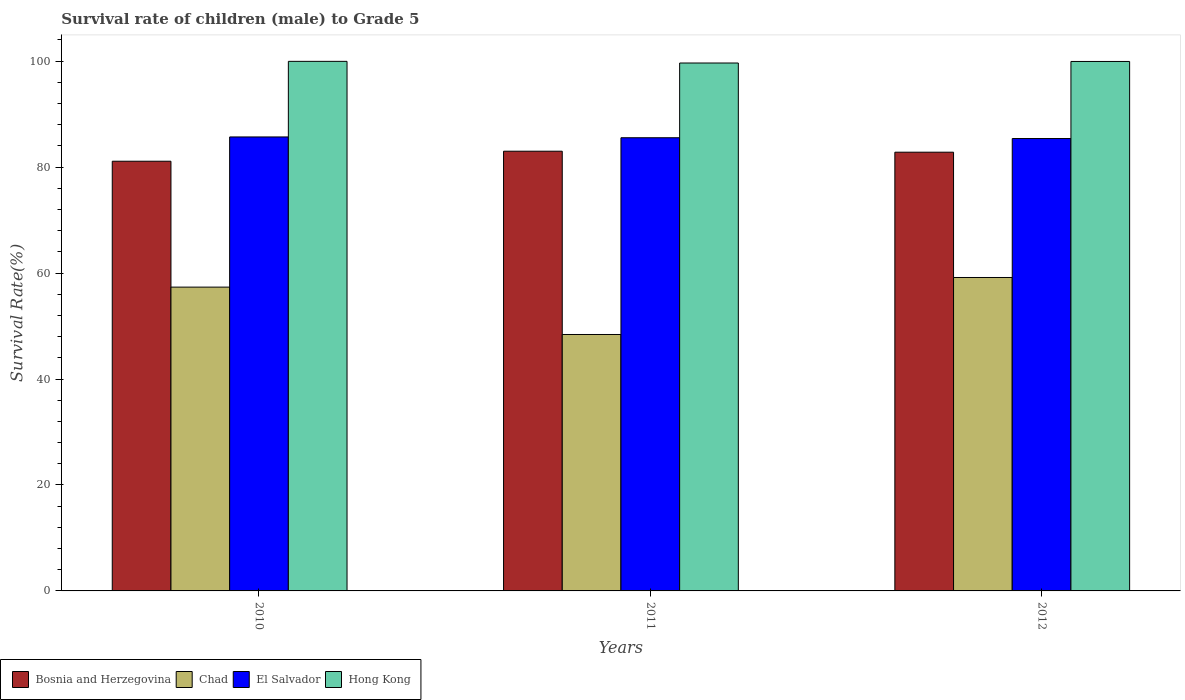How many different coloured bars are there?
Give a very brief answer. 4. Are the number of bars on each tick of the X-axis equal?
Provide a succinct answer. Yes. What is the survival rate of male children to grade 5 in El Salvador in 2011?
Your answer should be compact. 85.55. Across all years, what is the maximum survival rate of male children to grade 5 in Chad?
Provide a succinct answer. 59.17. Across all years, what is the minimum survival rate of male children to grade 5 in Hong Kong?
Provide a succinct answer. 99.65. In which year was the survival rate of male children to grade 5 in El Salvador minimum?
Provide a short and direct response. 2012. What is the total survival rate of male children to grade 5 in Bosnia and Herzegovina in the graph?
Ensure brevity in your answer.  246.93. What is the difference between the survival rate of male children to grade 5 in Chad in 2011 and that in 2012?
Your answer should be compact. -10.76. What is the difference between the survival rate of male children to grade 5 in Chad in 2011 and the survival rate of male children to grade 5 in Bosnia and Herzegovina in 2012?
Provide a short and direct response. -34.41. What is the average survival rate of male children to grade 5 in Hong Kong per year?
Provide a short and direct response. 99.85. In the year 2011, what is the difference between the survival rate of male children to grade 5 in Chad and survival rate of male children to grade 5 in Bosnia and Herzegovina?
Ensure brevity in your answer.  -34.6. What is the ratio of the survival rate of male children to grade 5 in El Salvador in 2010 to that in 2011?
Make the answer very short. 1. Is the difference between the survival rate of male children to grade 5 in Chad in 2010 and 2011 greater than the difference between the survival rate of male children to grade 5 in Bosnia and Herzegovina in 2010 and 2011?
Provide a succinct answer. Yes. What is the difference between the highest and the second highest survival rate of male children to grade 5 in El Salvador?
Make the answer very short. 0.15. What is the difference between the highest and the lowest survival rate of male children to grade 5 in El Salvador?
Keep it short and to the point. 0.3. In how many years, is the survival rate of male children to grade 5 in El Salvador greater than the average survival rate of male children to grade 5 in El Salvador taken over all years?
Provide a succinct answer. 2. What does the 4th bar from the left in 2011 represents?
Your answer should be very brief. Hong Kong. What does the 4th bar from the right in 2012 represents?
Your answer should be compact. Bosnia and Herzegovina. Is it the case that in every year, the sum of the survival rate of male children to grade 5 in Chad and survival rate of male children to grade 5 in Bosnia and Herzegovina is greater than the survival rate of male children to grade 5 in El Salvador?
Make the answer very short. Yes. Are all the bars in the graph horizontal?
Your response must be concise. No. What is the difference between two consecutive major ticks on the Y-axis?
Your answer should be very brief. 20. Are the values on the major ticks of Y-axis written in scientific E-notation?
Your answer should be very brief. No. Does the graph contain grids?
Make the answer very short. No. How are the legend labels stacked?
Provide a short and direct response. Horizontal. What is the title of the graph?
Your answer should be compact. Survival rate of children (male) to Grade 5. Does "Liechtenstein" appear as one of the legend labels in the graph?
Make the answer very short. No. What is the label or title of the X-axis?
Make the answer very short. Years. What is the label or title of the Y-axis?
Keep it short and to the point. Survival Rate(%). What is the Survival Rate(%) of Bosnia and Herzegovina in 2010?
Offer a very short reply. 81.11. What is the Survival Rate(%) in Chad in 2010?
Offer a very short reply. 57.35. What is the Survival Rate(%) in El Salvador in 2010?
Make the answer very short. 85.7. What is the Survival Rate(%) of Hong Kong in 2010?
Your answer should be compact. 99.96. What is the Survival Rate(%) in Bosnia and Herzegovina in 2011?
Your answer should be very brief. 83. What is the Survival Rate(%) of Chad in 2011?
Give a very brief answer. 48.41. What is the Survival Rate(%) of El Salvador in 2011?
Your answer should be compact. 85.55. What is the Survival Rate(%) in Hong Kong in 2011?
Give a very brief answer. 99.65. What is the Survival Rate(%) in Bosnia and Herzegovina in 2012?
Make the answer very short. 82.82. What is the Survival Rate(%) of Chad in 2012?
Provide a short and direct response. 59.17. What is the Survival Rate(%) of El Salvador in 2012?
Provide a short and direct response. 85.4. What is the Survival Rate(%) in Hong Kong in 2012?
Your answer should be compact. 99.95. Across all years, what is the maximum Survival Rate(%) in Bosnia and Herzegovina?
Provide a succinct answer. 83. Across all years, what is the maximum Survival Rate(%) in Chad?
Make the answer very short. 59.17. Across all years, what is the maximum Survival Rate(%) of El Salvador?
Offer a very short reply. 85.7. Across all years, what is the maximum Survival Rate(%) of Hong Kong?
Make the answer very short. 99.96. Across all years, what is the minimum Survival Rate(%) in Bosnia and Herzegovina?
Make the answer very short. 81.11. Across all years, what is the minimum Survival Rate(%) in Chad?
Ensure brevity in your answer.  48.41. Across all years, what is the minimum Survival Rate(%) of El Salvador?
Make the answer very short. 85.4. Across all years, what is the minimum Survival Rate(%) of Hong Kong?
Give a very brief answer. 99.65. What is the total Survival Rate(%) of Bosnia and Herzegovina in the graph?
Offer a terse response. 246.93. What is the total Survival Rate(%) in Chad in the graph?
Give a very brief answer. 164.92. What is the total Survival Rate(%) of El Salvador in the graph?
Your answer should be very brief. 256.64. What is the total Survival Rate(%) of Hong Kong in the graph?
Provide a short and direct response. 299.56. What is the difference between the Survival Rate(%) of Bosnia and Herzegovina in 2010 and that in 2011?
Provide a short and direct response. -1.89. What is the difference between the Survival Rate(%) in Chad in 2010 and that in 2011?
Your answer should be very brief. 8.94. What is the difference between the Survival Rate(%) in El Salvador in 2010 and that in 2011?
Offer a very short reply. 0.15. What is the difference between the Survival Rate(%) in Hong Kong in 2010 and that in 2011?
Keep it short and to the point. 0.31. What is the difference between the Survival Rate(%) of Bosnia and Herzegovina in 2010 and that in 2012?
Ensure brevity in your answer.  -1.7. What is the difference between the Survival Rate(%) of Chad in 2010 and that in 2012?
Make the answer very short. -1.82. What is the difference between the Survival Rate(%) in El Salvador in 2010 and that in 2012?
Provide a short and direct response. 0.3. What is the difference between the Survival Rate(%) in Hong Kong in 2010 and that in 2012?
Offer a very short reply. 0.02. What is the difference between the Survival Rate(%) of Bosnia and Herzegovina in 2011 and that in 2012?
Provide a succinct answer. 0.19. What is the difference between the Survival Rate(%) in Chad in 2011 and that in 2012?
Ensure brevity in your answer.  -10.76. What is the difference between the Survival Rate(%) of El Salvador in 2011 and that in 2012?
Your answer should be very brief. 0.15. What is the difference between the Survival Rate(%) in Hong Kong in 2011 and that in 2012?
Ensure brevity in your answer.  -0.29. What is the difference between the Survival Rate(%) of Bosnia and Herzegovina in 2010 and the Survival Rate(%) of Chad in 2011?
Keep it short and to the point. 32.71. What is the difference between the Survival Rate(%) of Bosnia and Herzegovina in 2010 and the Survival Rate(%) of El Salvador in 2011?
Your response must be concise. -4.43. What is the difference between the Survival Rate(%) of Bosnia and Herzegovina in 2010 and the Survival Rate(%) of Hong Kong in 2011?
Give a very brief answer. -18.54. What is the difference between the Survival Rate(%) of Chad in 2010 and the Survival Rate(%) of El Salvador in 2011?
Keep it short and to the point. -28.2. What is the difference between the Survival Rate(%) of Chad in 2010 and the Survival Rate(%) of Hong Kong in 2011?
Your answer should be very brief. -42.31. What is the difference between the Survival Rate(%) in El Salvador in 2010 and the Survival Rate(%) in Hong Kong in 2011?
Ensure brevity in your answer.  -13.96. What is the difference between the Survival Rate(%) in Bosnia and Herzegovina in 2010 and the Survival Rate(%) in Chad in 2012?
Provide a short and direct response. 21.95. What is the difference between the Survival Rate(%) of Bosnia and Herzegovina in 2010 and the Survival Rate(%) of El Salvador in 2012?
Give a very brief answer. -4.28. What is the difference between the Survival Rate(%) of Bosnia and Herzegovina in 2010 and the Survival Rate(%) of Hong Kong in 2012?
Keep it short and to the point. -18.83. What is the difference between the Survival Rate(%) of Chad in 2010 and the Survival Rate(%) of El Salvador in 2012?
Provide a succinct answer. -28.05. What is the difference between the Survival Rate(%) in Chad in 2010 and the Survival Rate(%) in Hong Kong in 2012?
Keep it short and to the point. -42.6. What is the difference between the Survival Rate(%) in El Salvador in 2010 and the Survival Rate(%) in Hong Kong in 2012?
Make the answer very short. -14.25. What is the difference between the Survival Rate(%) in Bosnia and Herzegovina in 2011 and the Survival Rate(%) in Chad in 2012?
Provide a short and direct response. 23.84. What is the difference between the Survival Rate(%) in Bosnia and Herzegovina in 2011 and the Survival Rate(%) in El Salvador in 2012?
Provide a short and direct response. -2.39. What is the difference between the Survival Rate(%) of Bosnia and Herzegovina in 2011 and the Survival Rate(%) of Hong Kong in 2012?
Your answer should be compact. -16.94. What is the difference between the Survival Rate(%) in Chad in 2011 and the Survival Rate(%) in El Salvador in 2012?
Your answer should be very brief. -36.99. What is the difference between the Survival Rate(%) of Chad in 2011 and the Survival Rate(%) of Hong Kong in 2012?
Keep it short and to the point. -51.54. What is the difference between the Survival Rate(%) in El Salvador in 2011 and the Survival Rate(%) in Hong Kong in 2012?
Offer a very short reply. -14.4. What is the average Survival Rate(%) in Bosnia and Herzegovina per year?
Your answer should be very brief. 82.31. What is the average Survival Rate(%) in Chad per year?
Offer a very short reply. 54.97. What is the average Survival Rate(%) in El Salvador per year?
Provide a short and direct response. 85.55. What is the average Survival Rate(%) in Hong Kong per year?
Your answer should be compact. 99.85. In the year 2010, what is the difference between the Survival Rate(%) in Bosnia and Herzegovina and Survival Rate(%) in Chad?
Your answer should be compact. 23.76. In the year 2010, what is the difference between the Survival Rate(%) of Bosnia and Herzegovina and Survival Rate(%) of El Salvador?
Offer a terse response. -4.58. In the year 2010, what is the difference between the Survival Rate(%) of Bosnia and Herzegovina and Survival Rate(%) of Hong Kong?
Your answer should be compact. -18.85. In the year 2010, what is the difference between the Survival Rate(%) of Chad and Survival Rate(%) of El Salvador?
Ensure brevity in your answer.  -28.35. In the year 2010, what is the difference between the Survival Rate(%) in Chad and Survival Rate(%) in Hong Kong?
Offer a very short reply. -42.62. In the year 2010, what is the difference between the Survival Rate(%) of El Salvador and Survival Rate(%) of Hong Kong?
Provide a short and direct response. -14.27. In the year 2011, what is the difference between the Survival Rate(%) in Bosnia and Herzegovina and Survival Rate(%) in Chad?
Keep it short and to the point. 34.6. In the year 2011, what is the difference between the Survival Rate(%) in Bosnia and Herzegovina and Survival Rate(%) in El Salvador?
Ensure brevity in your answer.  -2.54. In the year 2011, what is the difference between the Survival Rate(%) in Bosnia and Herzegovina and Survival Rate(%) in Hong Kong?
Keep it short and to the point. -16.65. In the year 2011, what is the difference between the Survival Rate(%) in Chad and Survival Rate(%) in El Salvador?
Provide a short and direct response. -37.14. In the year 2011, what is the difference between the Survival Rate(%) of Chad and Survival Rate(%) of Hong Kong?
Ensure brevity in your answer.  -51.25. In the year 2011, what is the difference between the Survival Rate(%) in El Salvador and Survival Rate(%) in Hong Kong?
Offer a terse response. -14.11. In the year 2012, what is the difference between the Survival Rate(%) of Bosnia and Herzegovina and Survival Rate(%) of Chad?
Provide a succinct answer. 23.65. In the year 2012, what is the difference between the Survival Rate(%) of Bosnia and Herzegovina and Survival Rate(%) of El Salvador?
Your response must be concise. -2.58. In the year 2012, what is the difference between the Survival Rate(%) in Bosnia and Herzegovina and Survival Rate(%) in Hong Kong?
Offer a very short reply. -17.13. In the year 2012, what is the difference between the Survival Rate(%) in Chad and Survival Rate(%) in El Salvador?
Your answer should be compact. -26.23. In the year 2012, what is the difference between the Survival Rate(%) in Chad and Survival Rate(%) in Hong Kong?
Ensure brevity in your answer.  -40.78. In the year 2012, what is the difference between the Survival Rate(%) of El Salvador and Survival Rate(%) of Hong Kong?
Provide a short and direct response. -14.55. What is the ratio of the Survival Rate(%) in Bosnia and Herzegovina in 2010 to that in 2011?
Give a very brief answer. 0.98. What is the ratio of the Survival Rate(%) in Chad in 2010 to that in 2011?
Offer a terse response. 1.18. What is the ratio of the Survival Rate(%) of El Salvador in 2010 to that in 2011?
Your answer should be compact. 1. What is the ratio of the Survival Rate(%) of Hong Kong in 2010 to that in 2011?
Offer a very short reply. 1. What is the ratio of the Survival Rate(%) of Bosnia and Herzegovina in 2010 to that in 2012?
Offer a very short reply. 0.98. What is the ratio of the Survival Rate(%) in Chad in 2010 to that in 2012?
Your response must be concise. 0.97. What is the ratio of the Survival Rate(%) in El Salvador in 2010 to that in 2012?
Your answer should be compact. 1. What is the ratio of the Survival Rate(%) of Hong Kong in 2010 to that in 2012?
Your answer should be very brief. 1. What is the ratio of the Survival Rate(%) of Bosnia and Herzegovina in 2011 to that in 2012?
Your response must be concise. 1. What is the ratio of the Survival Rate(%) in Chad in 2011 to that in 2012?
Your answer should be very brief. 0.82. What is the ratio of the Survival Rate(%) in El Salvador in 2011 to that in 2012?
Keep it short and to the point. 1. What is the ratio of the Survival Rate(%) of Hong Kong in 2011 to that in 2012?
Offer a terse response. 1. What is the difference between the highest and the second highest Survival Rate(%) in Bosnia and Herzegovina?
Your answer should be very brief. 0.19. What is the difference between the highest and the second highest Survival Rate(%) in Chad?
Offer a very short reply. 1.82. What is the difference between the highest and the second highest Survival Rate(%) of El Salvador?
Give a very brief answer. 0.15. What is the difference between the highest and the second highest Survival Rate(%) of Hong Kong?
Your response must be concise. 0.02. What is the difference between the highest and the lowest Survival Rate(%) in Bosnia and Herzegovina?
Offer a terse response. 1.89. What is the difference between the highest and the lowest Survival Rate(%) in Chad?
Offer a very short reply. 10.76. What is the difference between the highest and the lowest Survival Rate(%) in El Salvador?
Keep it short and to the point. 0.3. What is the difference between the highest and the lowest Survival Rate(%) of Hong Kong?
Keep it short and to the point. 0.31. 